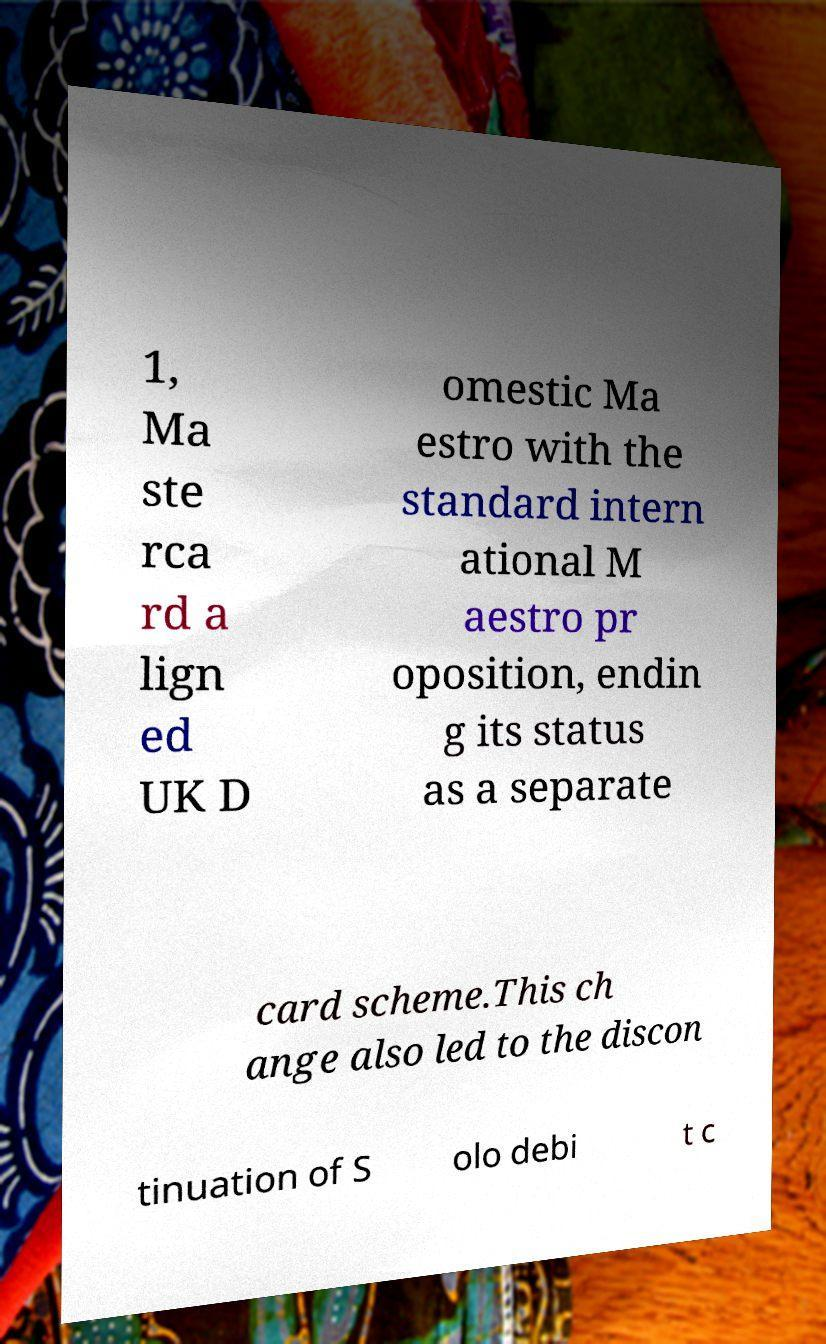What messages or text are displayed in this image? I need them in a readable, typed format. 1, Ma ste rca rd a lign ed UK D omestic Ma estro with the standard intern ational M aestro pr oposition, endin g its status as a separate card scheme.This ch ange also led to the discon tinuation of S olo debi t c 